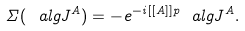<formula> <loc_0><loc_0><loc_500><loc_500>\Sigma ( \ a l g { J } ^ { A } ) = - e ^ { - i [ [ A ] ] p } \ a l g { J } ^ { A } .</formula> 